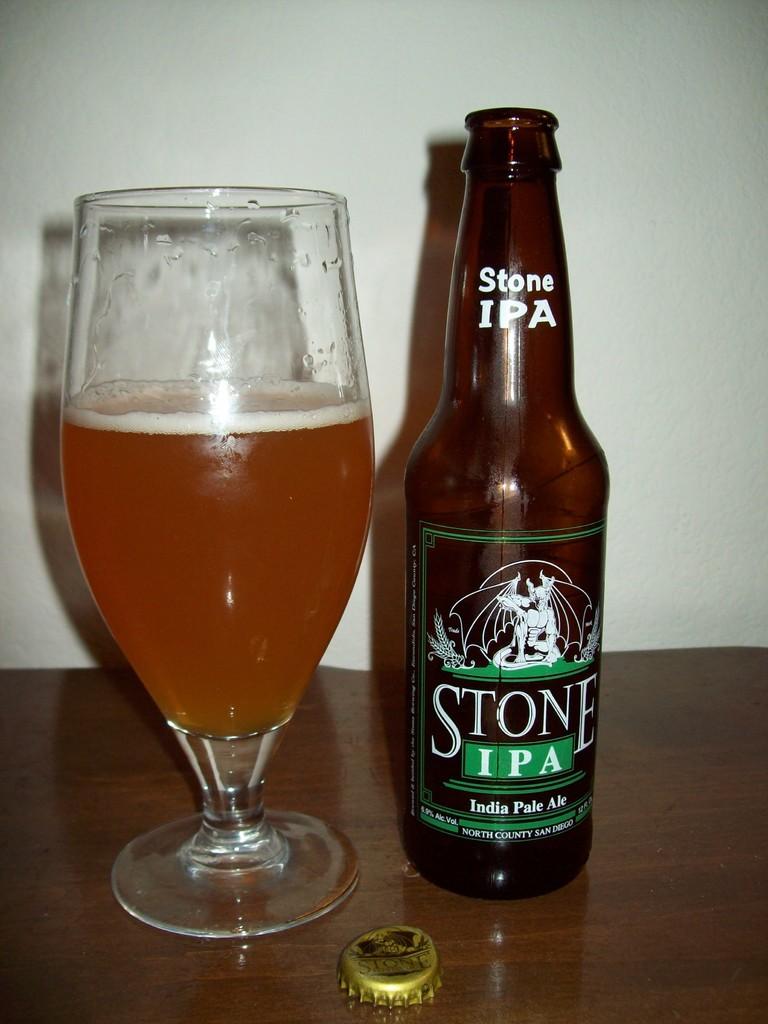What kind of ale is stone ipa?
Keep it short and to the point. India pale ale. 